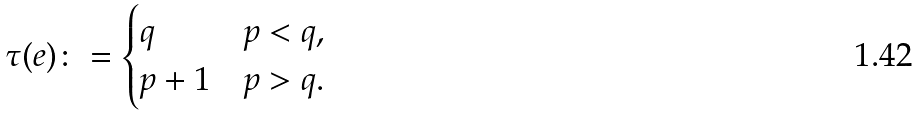<formula> <loc_0><loc_0><loc_500><loc_500>\tau ( e ) \colon = \begin{cases} q & p < q , \\ p + 1 & p > q . \end{cases}</formula> 